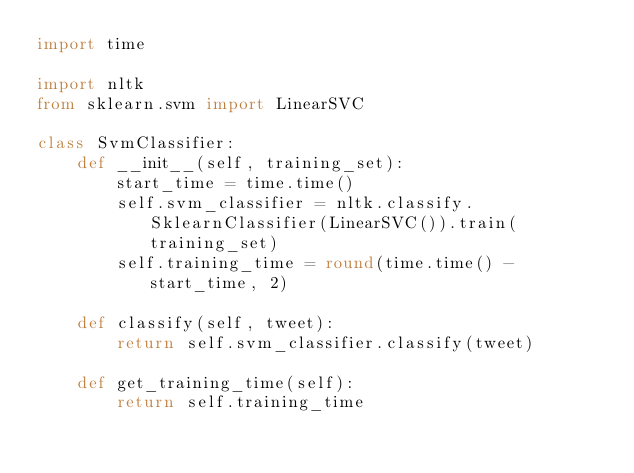Convert code to text. <code><loc_0><loc_0><loc_500><loc_500><_Python_>import time

import nltk
from sklearn.svm import LinearSVC

class SvmClassifier:
    def __init__(self, training_set):
        start_time = time.time()
        self.svm_classifier = nltk.classify.SklearnClassifier(LinearSVC()).train(training_set)
        self.training_time = round(time.time() - start_time, 2)

    def classify(self, tweet):
        return self.svm_classifier.classify(tweet)

    def get_training_time(self):
        return self.training_time
</code> 